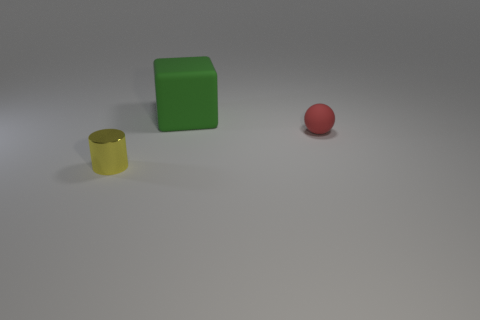Add 1 rubber cubes. How many objects exist? 4 Subtract all spheres. How many objects are left? 2 Add 2 large objects. How many large objects exist? 3 Subtract 0 cyan balls. How many objects are left? 3 Subtract all metal things. Subtract all small yellow shiny cylinders. How many objects are left? 1 Add 1 red spheres. How many red spheres are left? 2 